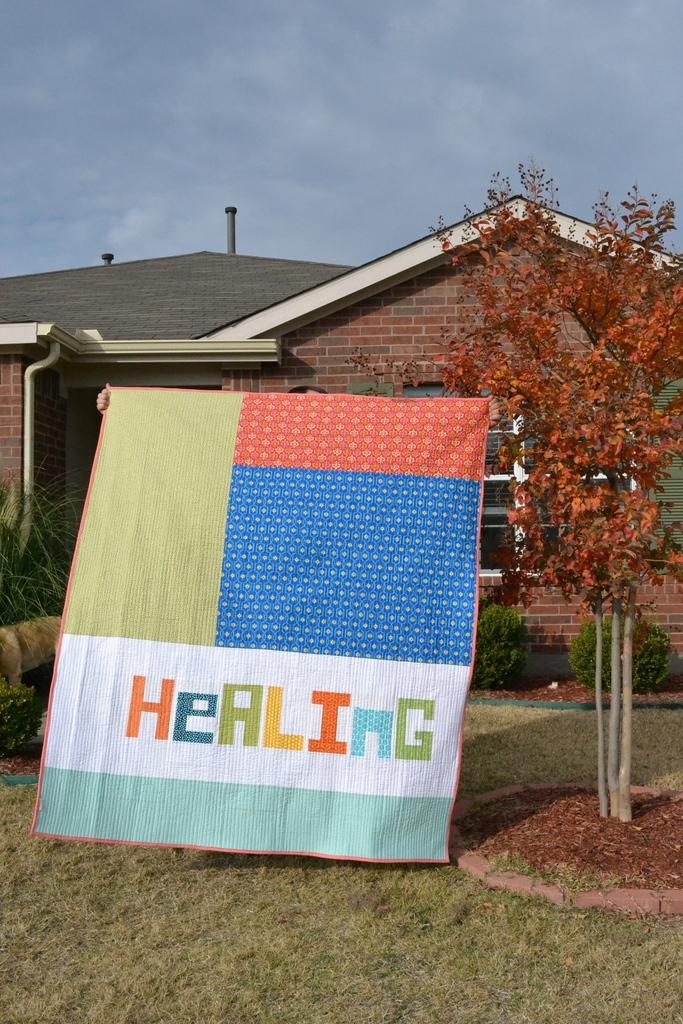What is the person holding in the image? The person is holding a mat in the image. What is located near the person? There is a tree beside the person. What can be seen in the background of the image? There is a house and clouds visible in the background of the image. What type of guitar is the person playing in the image? There is no guitar present in the image; the person is holding a mat. How does the person show care for the environment in the image? The image does not provide information about the person's actions or intentions related to caring for the environment. 